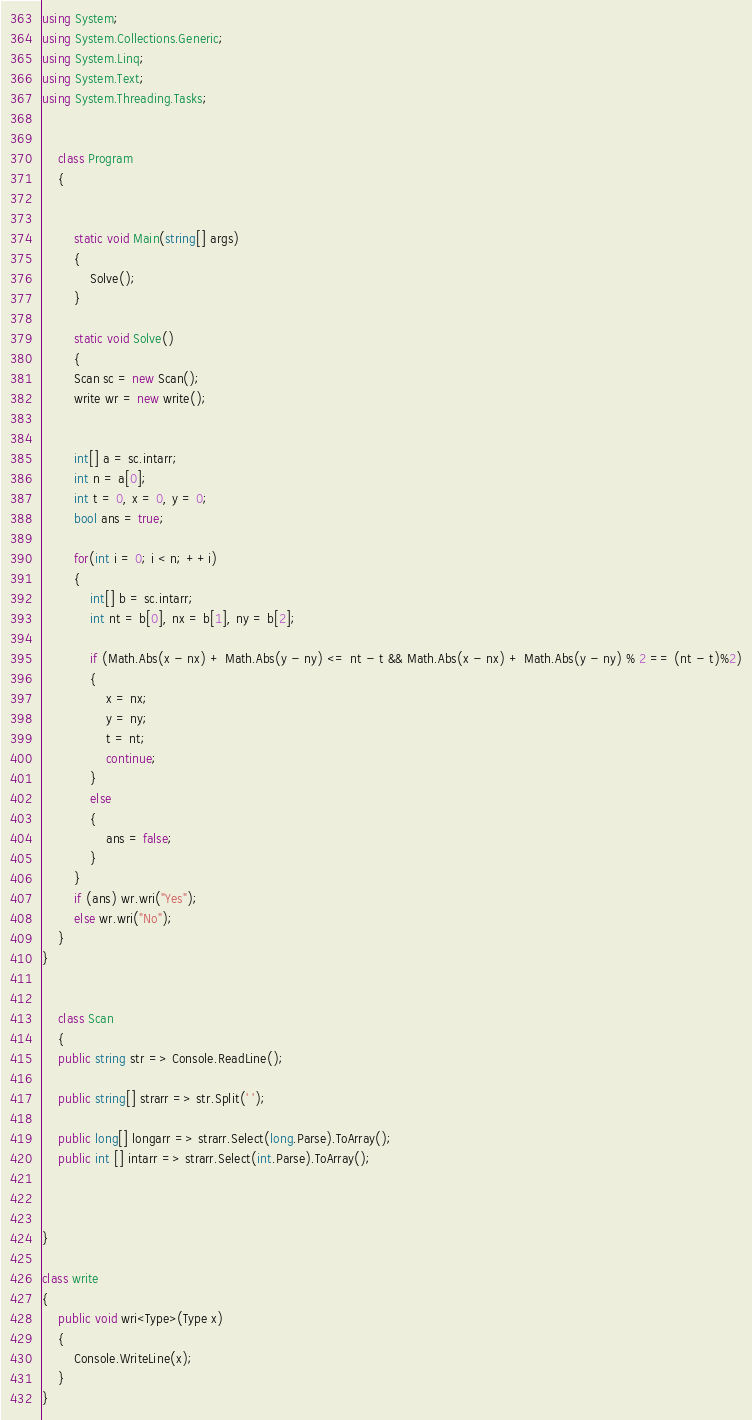<code> <loc_0><loc_0><loc_500><loc_500><_C#_>using System;
using System.Collections.Generic;
using System.Linq;
using System.Text;
using System.Threading.Tasks;


    class Program
    {


        static void Main(string[] args)
        {
            Solve();
        }

        static void Solve()
        {
        Scan sc = new Scan();
        write wr = new write();


        int[] a = sc.intarr;
        int n = a[0];
        int t = 0, x = 0, y = 0;
        bool ans = true;

        for(int i = 0; i < n; ++i)
        {
            int[] b = sc.intarr;
            int nt = b[0], nx = b[1], ny = b[2];

            if (Math.Abs(x - nx) + Math.Abs(y - ny) <= nt - t && Math.Abs(x - nx) + Math.Abs(y - ny) % 2 == (nt - t)%2)
            {
                x = nx;
                y = ny;
                t = nt;
                continue;
            }
            else
            {
                ans = false;
            }
        }
        if (ans) wr.wri("Yes");
        else wr.wri("No");
    }
}


    class Scan
    {
    public string str => Console.ReadLine();

    public string[] strarr => str.Split(' ');

    public long[] longarr => strarr.Select(long.Parse).ToArray();
    public int [] intarr => strarr.Select(int.Parse).ToArray();



}

class write
{
    public void wri<Type>(Type x)
    {
        Console.WriteLine(x);
    }
}
</code> 